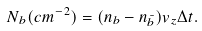<formula> <loc_0><loc_0><loc_500><loc_500>N _ { b } ( c m ^ { - 2 } ) = ( n _ { b } - n _ { \bar { b } } ) v _ { z } \Delta t .</formula> 